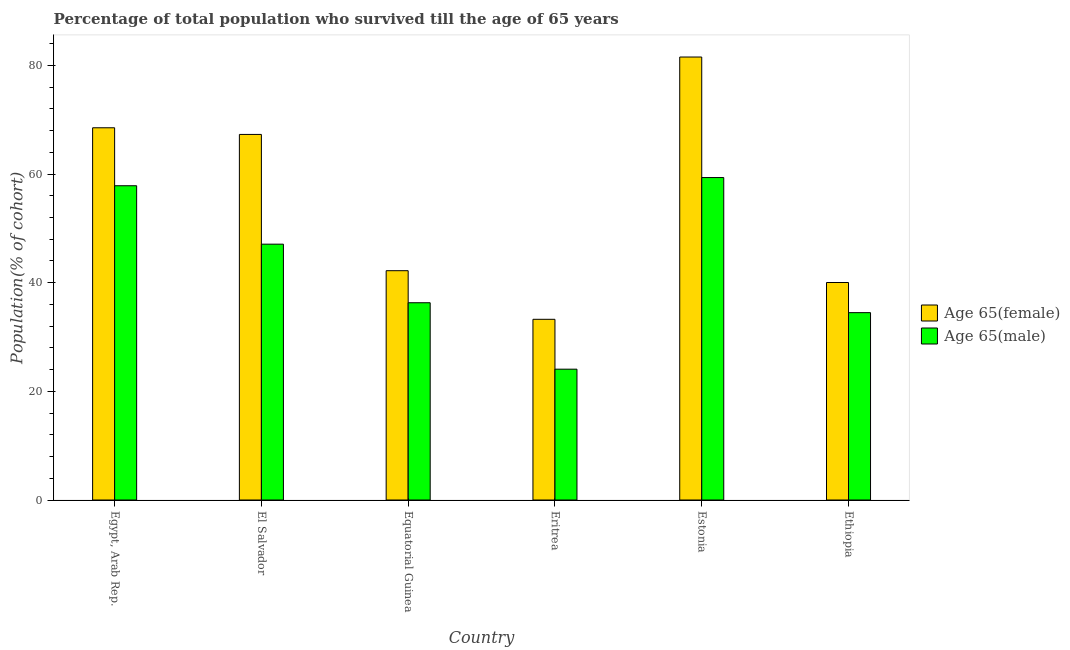How many different coloured bars are there?
Make the answer very short. 2. How many groups of bars are there?
Your response must be concise. 6. Are the number of bars on each tick of the X-axis equal?
Make the answer very short. Yes. How many bars are there on the 2nd tick from the right?
Offer a very short reply. 2. What is the label of the 5th group of bars from the left?
Your answer should be compact. Estonia. In how many cases, is the number of bars for a given country not equal to the number of legend labels?
Provide a short and direct response. 0. What is the percentage of female population who survived till age of 65 in Eritrea?
Keep it short and to the point. 33.26. Across all countries, what is the maximum percentage of female population who survived till age of 65?
Provide a short and direct response. 81.54. Across all countries, what is the minimum percentage of male population who survived till age of 65?
Make the answer very short. 24.08. In which country was the percentage of male population who survived till age of 65 maximum?
Keep it short and to the point. Estonia. In which country was the percentage of female population who survived till age of 65 minimum?
Ensure brevity in your answer.  Eritrea. What is the total percentage of male population who survived till age of 65 in the graph?
Provide a short and direct response. 259.17. What is the difference between the percentage of female population who survived till age of 65 in El Salvador and that in Eritrea?
Offer a very short reply. 34.03. What is the difference between the percentage of male population who survived till age of 65 in Estonia and the percentage of female population who survived till age of 65 in Equatorial Guinea?
Offer a terse response. 17.14. What is the average percentage of male population who survived till age of 65 per country?
Keep it short and to the point. 43.19. What is the difference between the percentage of male population who survived till age of 65 and percentage of female population who survived till age of 65 in Ethiopia?
Offer a terse response. -5.55. What is the ratio of the percentage of male population who survived till age of 65 in El Salvador to that in Ethiopia?
Provide a succinct answer. 1.37. Is the percentage of female population who survived till age of 65 in Estonia less than that in Ethiopia?
Ensure brevity in your answer.  No. What is the difference between the highest and the second highest percentage of female population who survived till age of 65?
Provide a succinct answer. 13.02. What is the difference between the highest and the lowest percentage of female population who survived till age of 65?
Offer a terse response. 48.28. In how many countries, is the percentage of male population who survived till age of 65 greater than the average percentage of male population who survived till age of 65 taken over all countries?
Offer a very short reply. 3. Is the sum of the percentage of male population who survived till age of 65 in El Salvador and Ethiopia greater than the maximum percentage of female population who survived till age of 65 across all countries?
Ensure brevity in your answer.  Yes. What does the 2nd bar from the left in Ethiopia represents?
Offer a terse response. Age 65(male). What does the 2nd bar from the right in El Salvador represents?
Offer a terse response. Age 65(female). Are all the bars in the graph horizontal?
Your response must be concise. No. What is the difference between two consecutive major ticks on the Y-axis?
Ensure brevity in your answer.  20. Does the graph contain grids?
Keep it short and to the point. No. Where does the legend appear in the graph?
Keep it short and to the point. Center right. What is the title of the graph?
Your answer should be very brief. Percentage of total population who survived till the age of 65 years. Does "Private creditors" appear as one of the legend labels in the graph?
Offer a terse response. No. What is the label or title of the X-axis?
Provide a short and direct response. Country. What is the label or title of the Y-axis?
Your response must be concise. Population(% of cohort). What is the Population(% of cohort) of Age 65(female) in Egypt, Arab Rep.?
Provide a succinct answer. 68.52. What is the Population(% of cohort) of Age 65(male) in Egypt, Arab Rep.?
Offer a very short reply. 57.85. What is the Population(% of cohort) of Age 65(female) in El Salvador?
Provide a short and direct response. 67.29. What is the Population(% of cohort) in Age 65(male) in El Salvador?
Offer a terse response. 47.09. What is the Population(% of cohort) of Age 65(female) in Equatorial Guinea?
Provide a short and direct response. 42.21. What is the Population(% of cohort) in Age 65(male) in Equatorial Guinea?
Your response must be concise. 36.31. What is the Population(% of cohort) in Age 65(female) in Eritrea?
Ensure brevity in your answer.  33.26. What is the Population(% of cohort) of Age 65(male) in Eritrea?
Provide a short and direct response. 24.08. What is the Population(% of cohort) in Age 65(female) in Estonia?
Offer a terse response. 81.54. What is the Population(% of cohort) in Age 65(male) in Estonia?
Provide a succinct answer. 59.35. What is the Population(% of cohort) in Age 65(female) in Ethiopia?
Your answer should be compact. 40.03. What is the Population(% of cohort) in Age 65(male) in Ethiopia?
Your response must be concise. 34.49. Across all countries, what is the maximum Population(% of cohort) in Age 65(female)?
Keep it short and to the point. 81.54. Across all countries, what is the maximum Population(% of cohort) in Age 65(male)?
Provide a succinct answer. 59.35. Across all countries, what is the minimum Population(% of cohort) in Age 65(female)?
Keep it short and to the point. 33.26. Across all countries, what is the minimum Population(% of cohort) of Age 65(male)?
Offer a terse response. 24.08. What is the total Population(% of cohort) in Age 65(female) in the graph?
Your response must be concise. 332.85. What is the total Population(% of cohort) in Age 65(male) in the graph?
Your answer should be compact. 259.17. What is the difference between the Population(% of cohort) of Age 65(female) in Egypt, Arab Rep. and that in El Salvador?
Make the answer very short. 1.22. What is the difference between the Population(% of cohort) in Age 65(male) in Egypt, Arab Rep. and that in El Salvador?
Keep it short and to the point. 10.75. What is the difference between the Population(% of cohort) in Age 65(female) in Egypt, Arab Rep. and that in Equatorial Guinea?
Your response must be concise. 26.31. What is the difference between the Population(% of cohort) of Age 65(male) in Egypt, Arab Rep. and that in Equatorial Guinea?
Keep it short and to the point. 21.54. What is the difference between the Population(% of cohort) of Age 65(female) in Egypt, Arab Rep. and that in Eritrea?
Make the answer very short. 35.26. What is the difference between the Population(% of cohort) in Age 65(male) in Egypt, Arab Rep. and that in Eritrea?
Your answer should be very brief. 33.76. What is the difference between the Population(% of cohort) in Age 65(female) in Egypt, Arab Rep. and that in Estonia?
Offer a very short reply. -13.02. What is the difference between the Population(% of cohort) of Age 65(male) in Egypt, Arab Rep. and that in Estonia?
Offer a terse response. -1.51. What is the difference between the Population(% of cohort) in Age 65(female) in Egypt, Arab Rep. and that in Ethiopia?
Provide a succinct answer. 28.48. What is the difference between the Population(% of cohort) in Age 65(male) in Egypt, Arab Rep. and that in Ethiopia?
Provide a short and direct response. 23.36. What is the difference between the Population(% of cohort) in Age 65(female) in El Salvador and that in Equatorial Guinea?
Ensure brevity in your answer.  25.08. What is the difference between the Population(% of cohort) in Age 65(male) in El Salvador and that in Equatorial Guinea?
Provide a short and direct response. 10.78. What is the difference between the Population(% of cohort) of Age 65(female) in El Salvador and that in Eritrea?
Your answer should be very brief. 34.03. What is the difference between the Population(% of cohort) of Age 65(male) in El Salvador and that in Eritrea?
Offer a very short reply. 23.01. What is the difference between the Population(% of cohort) of Age 65(female) in El Salvador and that in Estonia?
Your answer should be compact. -14.25. What is the difference between the Population(% of cohort) of Age 65(male) in El Salvador and that in Estonia?
Provide a succinct answer. -12.26. What is the difference between the Population(% of cohort) of Age 65(female) in El Salvador and that in Ethiopia?
Your answer should be compact. 27.26. What is the difference between the Population(% of cohort) of Age 65(male) in El Salvador and that in Ethiopia?
Offer a very short reply. 12.6. What is the difference between the Population(% of cohort) of Age 65(female) in Equatorial Guinea and that in Eritrea?
Ensure brevity in your answer.  8.95. What is the difference between the Population(% of cohort) of Age 65(male) in Equatorial Guinea and that in Eritrea?
Your response must be concise. 12.23. What is the difference between the Population(% of cohort) in Age 65(female) in Equatorial Guinea and that in Estonia?
Ensure brevity in your answer.  -39.33. What is the difference between the Population(% of cohort) of Age 65(male) in Equatorial Guinea and that in Estonia?
Your answer should be very brief. -23.04. What is the difference between the Population(% of cohort) in Age 65(female) in Equatorial Guinea and that in Ethiopia?
Offer a terse response. 2.17. What is the difference between the Population(% of cohort) in Age 65(male) in Equatorial Guinea and that in Ethiopia?
Offer a terse response. 1.82. What is the difference between the Population(% of cohort) in Age 65(female) in Eritrea and that in Estonia?
Give a very brief answer. -48.28. What is the difference between the Population(% of cohort) of Age 65(male) in Eritrea and that in Estonia?
Provide a succinct answer. -35.27. What is the difference between the Population(% of cohort) in Age 65(female) in Eritrea and that in Ethiopia?
Provide a succinct answer. -6.77. What is the difference between the Population(% of cohort) in Age 65(male) in Eritrea and that in Ethiopia?
Keep it short and to the point. -10.41. What is the difference between the Population(% of cohort) in Age 65(female) in Estonia and that in Ethiopia?
Your answer should be compact. 41.5. What is the difference between the Population(% of cohort) of Age 65(male) in Estonia and that in Ethiopia?
Ensure brevity in your answer.  24.86. What is the difference between the Population(% of cohort) of Age 65(female) in Egypt, Arab Rep. and the Population(% of cohort) of Age 65(male) in El Salvador?
Provide a short and direct response. 21.43. What is the difference between the Population(% of cohort) of Age 65(female) in Egypt, Arab Rep. and the Population(% of cohort) of Age 65(male) in Equatorial Guinea?
Your response must be concise. 32.21. What is the difference between the Population(% of cohort) of Age 65(female) in Egypt, Arab Rep. and the Population(% of cohort) of Age 65(male) in Eritrea?
Provide a short and direct response. 44.44. What is the difference between the Population(% of cohort) in Age 65(female) in Egypt, Arab Rep. and the Population(% of cohort) in Age 65(male) in Estonia?
Make the answer very short. 9.16. What is the difference between the Population(% of cohort) in Age 65(female) in Egypt, Arab Rep. and the Population(% of cohort) in Age 65(male) in Ethiopia?
Keep it short and to the point. 34.03. What is the difference between the Population(% of cohort) of Age 65(female) in El Salvador and the Population(% of cohort) of Age 65(male) in Equatorial Guinea?
Your answer should be compact. 30.98. What is the difference between the Population(% of cohort) in Age 65(female) in El Salvador and the Population(% of cohort) in Age 65(male) in Eritrea?
Your answer should be compact. 43.21. What is the difference between the Population(% of cohort) of Age 65(female) in El Salvador and the Population(% of cohort) of Age 65(male) in Estonia?
Your answer should be very brief. 7.94. What is the difference between the Population(% of cohort) of Age 65(female) in El Salvador and the Population(% of cohort) of Age 65(male) in Ethiopia?
Your answer should be very brief. 32.81. What is the difference between the Population(% of cohort) in Age 65(female) in Equatorial Guinea and the Population(% of cohort) in Age 65(male) in Eritrea?
Ensure brevity in your answer.  18.13. What is the difference between the Population(% of cohort) in Age 65(female) in Equatorial Guinea and the Population(% of cohort) in Age 65(male) in Estonia?
Keep it short and to the point. -17.14. What is the difference between the Population(% of cohort) of Age 65(female) in Equatorial Guinea and the Population(% of cohort) of Age 65(male) in Ethiopia?
Keep it short and to the point. 7.72. What is the difference between the Population(% of cohort) in Age 65(female) in Eritrea and the Population(% of cohort) in Age 65(male) in Estonia?
Offer a terse response. -26.09. What is the difference between the Population(% of cohort) in Age 65(female) in Eritrea and the Population(% of cohort) in Age 65(male) in Ethiopia?
Your answer should be compact. -1.23. What is the difference between the Population(% of cohort) of Age 65(female) in Estonia and the Population(% of cohort) of Age 65(male) in Ethiopia?
Your response must be concise. 47.05. What is the average Population(% of cohort) in Age 65(female) per country?
Your answer should be very brief. 55.48. What is the average Population(% of cohort) of Age 65(male) per country?
Provide a short and direct response. 43.19. What is the difference between the Population(% of cohort) of Age 65(female) and Population(% of cohort) of Age 65(male) in Egypt, Arab Rep.?
Offer a very short reply. 10.67. What is the difference between the Population(% of cohort) of Age 65(female) and Population(% of cohort) of Age 65(male) in El Salvador?
Provide a short and direct response. 20.2. What is the difference between the Population(% of cohort) of Age 65(female) and Population(% of cohort) of Age 65(male) in Equatorial Guinea?
Offer a terse response. 5.9. What is the difference between the Population(% of cohort) in Age 65(female) and Population(% of cohort) in Age 65(male) in Eritrea?
Keep it short and to the point. 9.18. What is the difference between the Population(% of cohort) of Age 65(female) and Population(% of cohort) of Age 65(male) in Estonia?
Give a very brief answer. 22.19. What is the difference between the Population(% of cohort) of Age 65(female) and Population(% of cohort) of Age 65(male) in Ethiopia?
Offer a terse response. 5.55. What is the ratio of the Population(% of cohort) of Age 65(female) in Egypt, Arab Rep. to that in El Salvador?
Provide a short and direct response. 1.02. What is the ratio of the Population(% of cohort) of Age 65(male) in Egypt, Arab Rep. to that in El Salvador?
Provide a short and direct response. 1.23. What is the ratio of the Population(% of cohort) of Age 65(female) in Egypt, Arab Rep. to that in Equatorial Guinea?
Provide a succinct answer. 1.62. What is the ratio of the Population(% of cohort) in Age 65(male) in Egypt, Arab Rep. to that in Equatorial Guinea?
Offer a very short reply. 1.59. What is the ratio of the Population(% of cohort) of Age 65(female) in Egypt, Arab Rep. to that in Eritrea?
Provide a succinct answer. 2.06. What is the ratio of the Population(% of cohort) in Age 65(male) in Egypt, Arab Rep. to that in Eritrea?
Make the answer very short. 2.4. What is the ratio of the Population(% of cohort) of Age 65(female) in Egypt, Arab Rep. to that in Estonia?
Provide a succinct answer. 0.84. What is the ratio of the Population(% of cohort) of Age 65(male) in Egypt, Arab Rep. to that in Estonia?
Your answer should be very brief. 0.97. What is the ratio of the Population(% of cohort) in Age 65(female) in Egypt, Arab Rep. to that in Ethiopia?
Give a very brief answer. 1.71. What is the ratio of the Population(% of cohort) in Age 65(male) in Egypt, Arab Rep. to that in Ethiopia?
Your answer should be very brief. 1.68. What is the ratio of the Population(% of cohort) of Age 65(female) in El Salvador to that in Equatorial Guinea?
Give a very brief answer. 1.59. What is the ratio of the Population(% of cohort) of Age 65(male) in El Salvador to that in Equatorial Guinea?
Your response must be concise. 1.3. What is the ratio of the Population(% of cohort) in Age 65(female) in El Salvador to that in Eritrea?
Give a very brief answer. 2.02. What is the ratio of the Population(% of cohort) in Age 65(male) in El Salvador to that in Eritrea?
Give a very brief answer. 1.96. What is the ratio of the Population(% of cohort) in Age 65(female) in El Salvador to that in Estonia?
Provide a short and direct response. 0.83. What is the ratio of the Population(% of cohort) of Age 65(male) in El Salvador to that in Estonia?
Offer a very short reply. 0.79. What is the ratio of the Population(% of cohort) in Age 65(female) in El Salvador to that in Ethiopia?
Offer a terse response. 1.68. What is the ratio of the Population(% of cohort) in Age 65(male) in El Salvador to that in Ethiopia?
Give a very brief answer. 1.37. What is the ratio of the Population(% of cohort) in Age 65(female) in Equatorial Guinea to that in Eritrea?
Give a very brief answer. 1.27. What is the ratio of the Population(% of cohort) in Age 65(male) in Equatorial Guinea to that in Eritrea?
Offer a very short reply. 1.51. What is the ratio of the Population(% of cohort) of Age 65(female) in Equatorial Guinea to that in Estonia?
Offer a terse response. 0.52. What is the ratio of the Population(% of cohort) in Age 65(male) in Equatorial Guinea to that in Estonia?
Make the answer very short. 0.61. What is the ratio of the Population(% of cohort) in Age 65(female) in Equatorial Guinea to that in Ethiopia?
Offer a very short reply. 1.05. What is the ratio of the Population(% of cohort) of Age 65(male) in Equatorial Guinea to that in Ethiopia?
Give a very brief answer. 1.05. What is the ratio of the Population(% of cohort) of Age 65(female) in Eritrea to that in Estonia?
Provide a succinct answer. 0.41. What is the ratio of the Population(% of cohort) of Age 65(male) in Eritrea to that in Estonia?
Give a very brief answer. 0.41. What is the ratio of the Population(% of cohort) in Age 65(female) in Eritrea to that in Ethiopia?
Your answer should be very brief. 0.83. What is the ratio of the Population(% of cohort) in Age 65(male) in Eritrea to that in Ethiopia?
Provide a short and direct response. 0.7. What is the ratio of the Population(% of cohort) in Age 65(female) in Estonia to that in Ethiopia?
Your response must be concise. 2.04. What is the ratio of the Population(% of cohort) of Age 65(male) in Estonia to that in Ethiopia?
Your response must be concise. 1.72. What is the difference between the highest and the second highest Population(% of cohort) of Age 65(female)?
Provide a succinct answer. 13.02. What is the difference between the highest and the second highest Population(% of cohort) in Age 65(male)?
Provide a short and direct response. 1.51. What is the difference between the highest and the lowest Population(% of cohort) in Age 65(female)?
Make the answer very short. 48.28. What is the difference between the highest and the lowest Population(% of cohort) of Age 65(male)?
Keep it short and to the point. 35.27. 